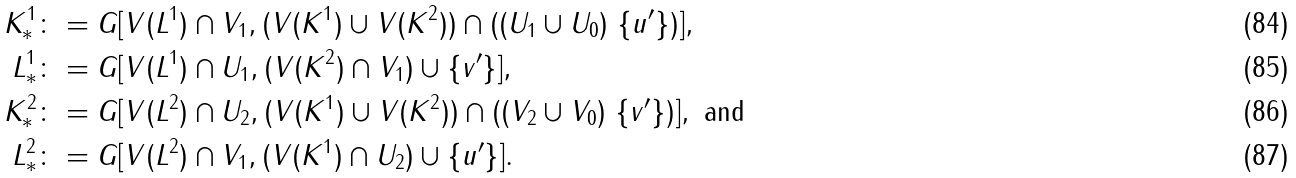<formula> <loc_0><loc_0><loc_500><loc_500>K ^ { 1 } _ { * } \colon & = G [ V ( L ^ { 1 } ) \cap V _ { 1 } , ( V ( K ^ { 1 } ) \cup V ( K ^ { 2 } ) ) \cap ( ( U _ { 1 } \cup U _ { 0 } ) \ \{ u ^ { \prime } \} ) ] , \\ L ^ { 1 } _ { * } \colon & = G [ V ( L ^ { 1 } ) \cap U _ { 1 } , ( V ( K ^ { 2 } ) \cap V _ { 1 } ) \cup \{ v ^ { \prime } \} ] , \\ K ^ { 2 } _ { * } \colon & = G [ V ( L ^ { 2 } ) \cap U _ { 2 } , ( V ( K ^ { 1 } ) \cup V ( K ^ { 2 } ) ) \cap ( ( V _ { 2 } \cup V _ { 0 } ) \ \{ v ^ { \prime } \} ) ] , \text { and} \\ L ^ { 2 } _ { * } \colon & = G [ V ( L ^ { 2 } ) \cap V _ { 1 } , ( V ( K ^ { 1 } ) \cap U _ { 2 } ) \cup \{ u ^ { \prime } \} ] .</formula> 